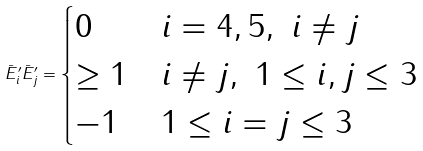Convert formula to latex. <formula><loc_0><loc_0><loc_500><loc_500>\bar { E } ^ { \prime } _ { i } \bar { E } ^ { \prime } _ { j } = \begin{cases} 0 & i = 4 , 5 , \ i \ne j \\ \geq 1 & i \ne j , \ 1 \leq i , j \leq 3 \\ - 1 & 1 \leq i = j \leq 3 \end{cases}</formula> 